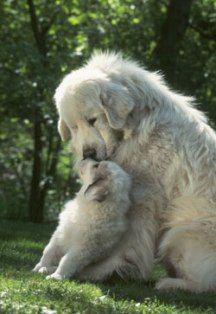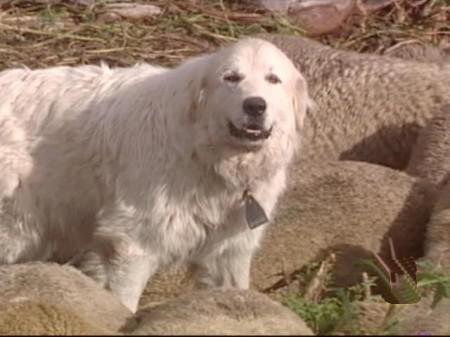The first image is the image on the left, the second image is the image on the right. Analyze the images presented: Is the assertion "Every image contains only one dog" valid? Answer yes or no. No. The first image is the image on the left, the second image is the image on the right. Examine the images to the left and right. Is the description "There is a lone dog facing the camera in one image and a dog with at least one puppy in the other image." accurate? Answer yes or no. Yes. 